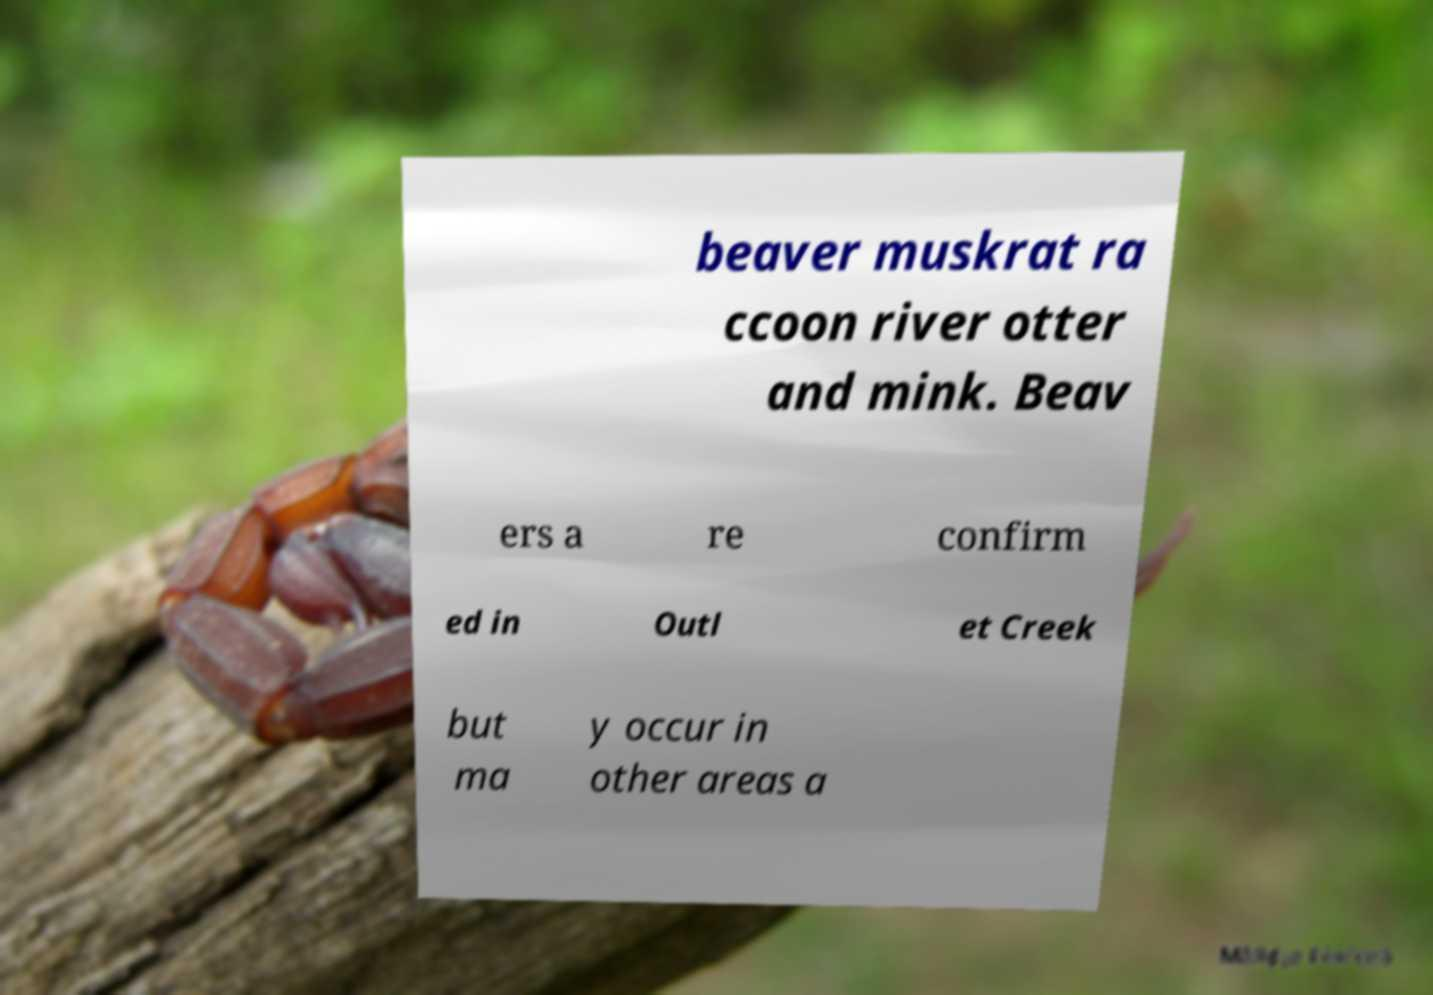Please read and relay the text visible in this image. What does it say? beaver muskrat ra ccoon river otter and mink. Beav ers a re confirm ed in Outl et Creek but ma y occur in other areas a 